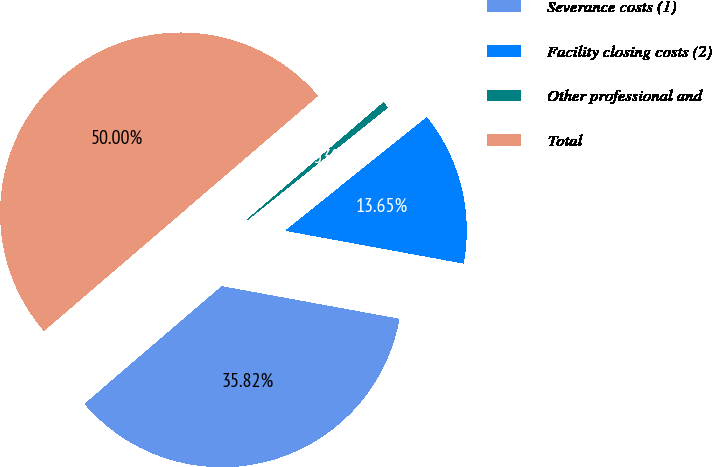<chart> <loc_0><loc_0><loc_500><loc_500><pie_chart><fcel>Severance costs (1)<fcel>Facility closing costs (2)<fcel>Other professional and<fcel>Total<nl><fcel>35.82%<fcel>13.65%<fcel>0.53%<fcel>50.0%<nl></chart> 